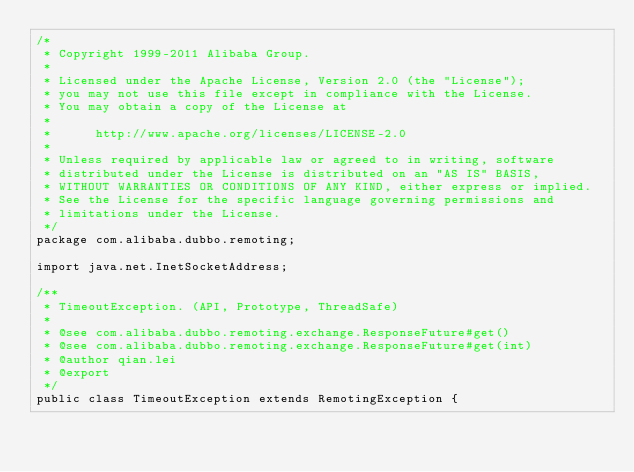Convert code to text. <code><loc_0><loc_0><loc_500><loc_500><_Java_>/*
 * Copyright 1999-2011 Alibaba Group.
 *  
 * Licensed under the Apache License, Version 2.0 (the "License");
 * you may not use this file except in compliance with the License.
 * You may obtain a copy of the License at
 *  
 *      http://www.apache.org/licenses/LICENSE-2.0
 *  
 * Unless required by applicable law or agreed to in writing, software
 * distributed under the License is distributed on an "AS IS" BASIS,
 * WITHOUT WARRANTIES OR CONDITIONS OF ANY KIND, either express or implied.
 * See the License for the specific language governing permissions and
 * limitations under the License.
 */
package com.alibaba.dubbo.remoting;

import java.net.InetSocketAddress;

/**
 * TimeoutException. (API, Prototype, ThreadSafe)
 * 
 * @see com.alibaba.dubbo.remoting.exchange.ResponseFuture#get()
 * @see com.alibaba.dubbo.remoting.exchange.ResponseFuture#get(int)
 * @author qian.lei
 * @export
 */
public class TimeoutException extends RemotingException {
</code> 